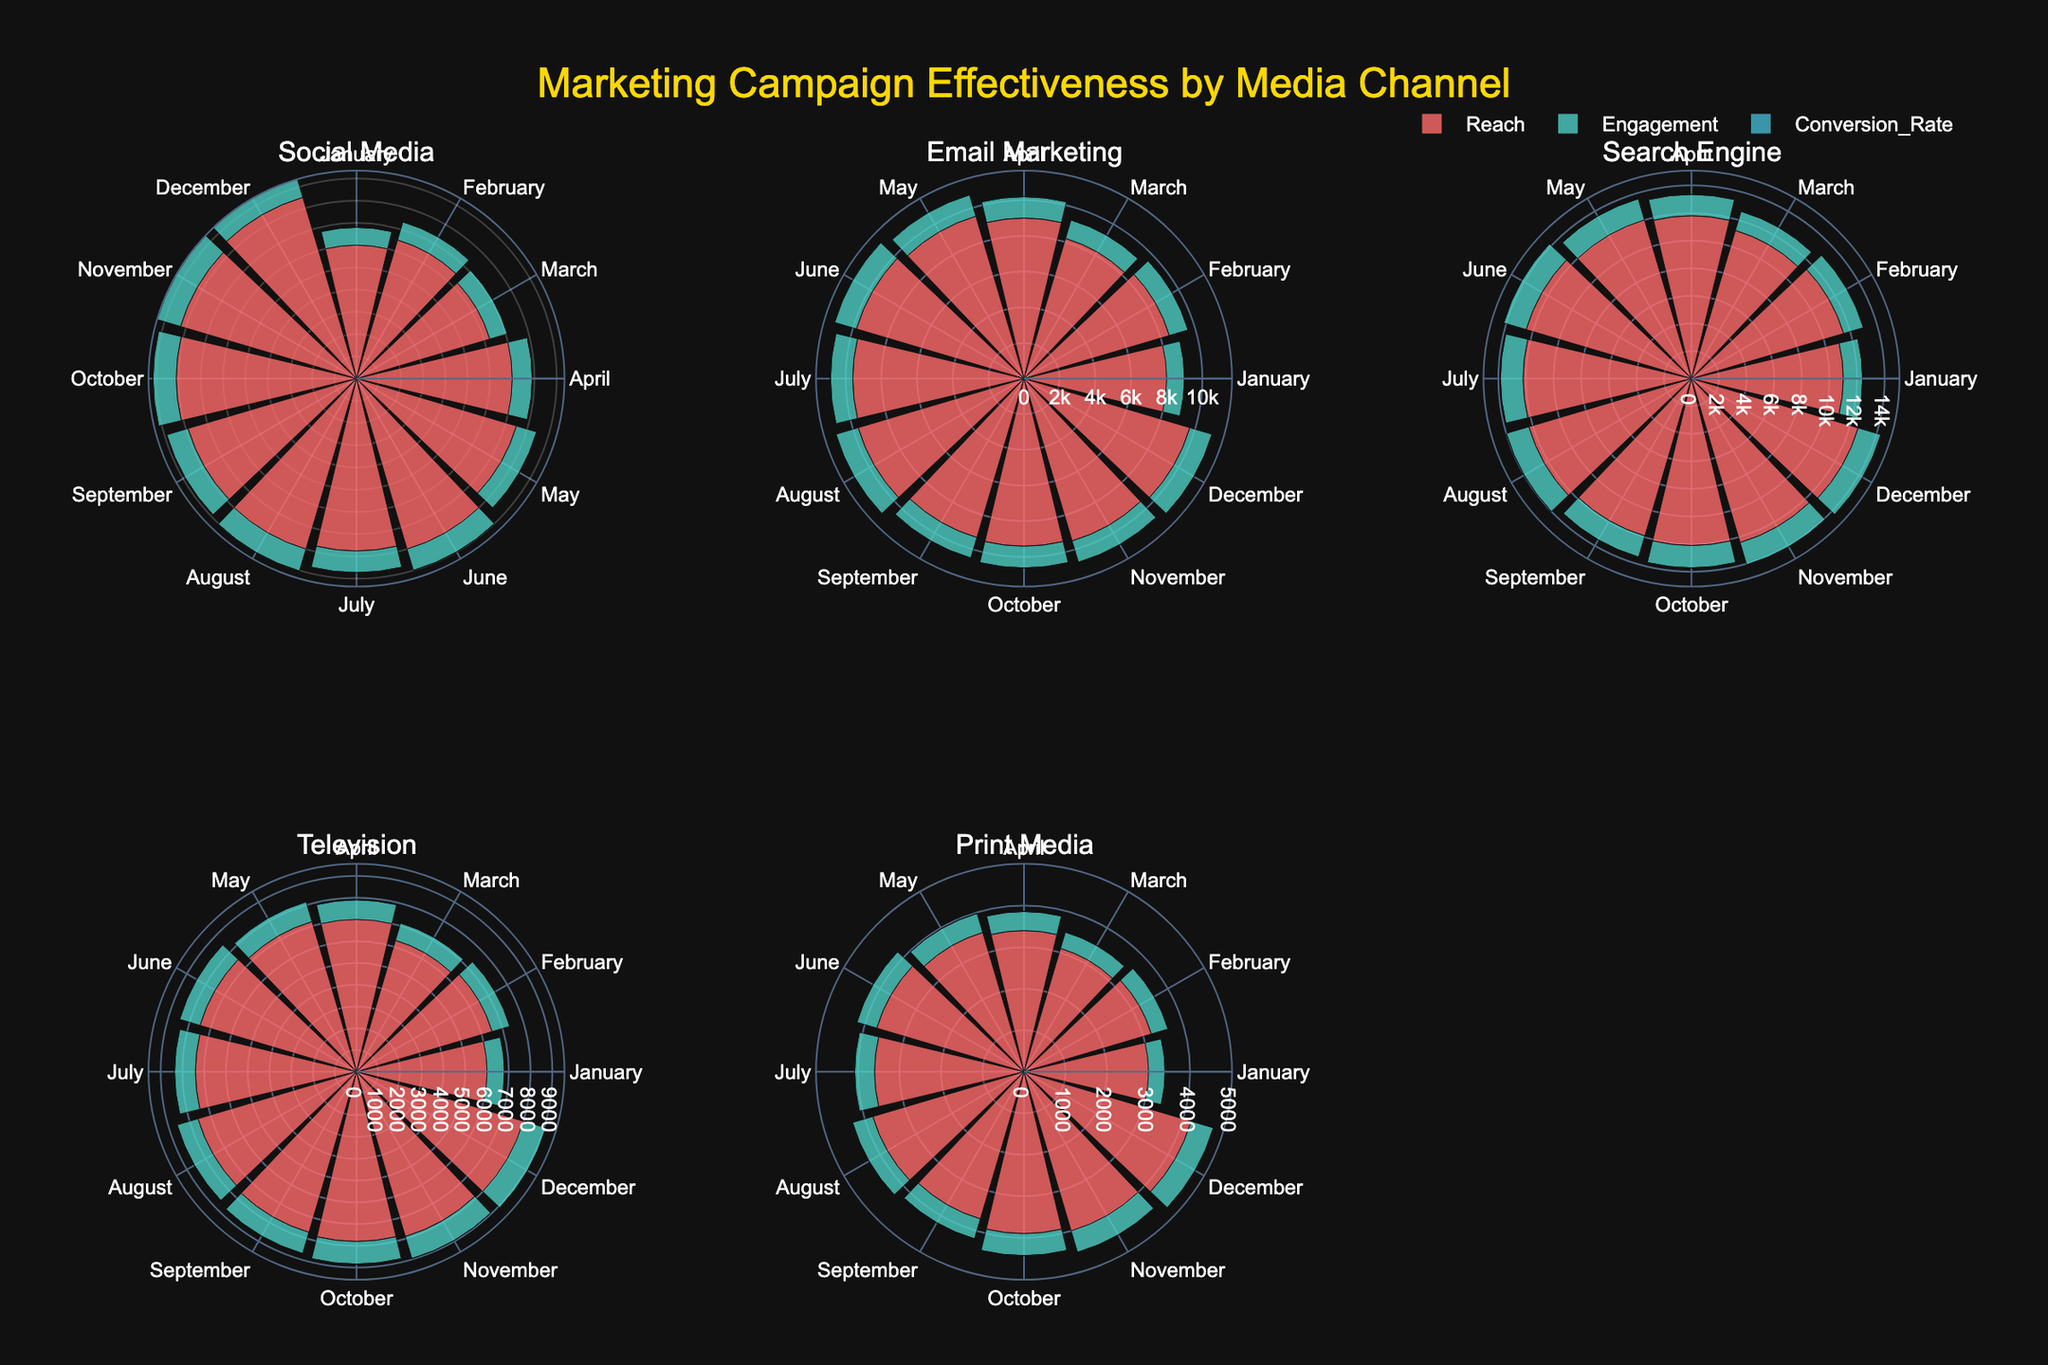What is the total number of media channels shown in the figure? The figure has a separate subplot for each media channel. By counting the subplot titles, we can determine the total number of media channels.
Answer: 5 Which month shows the highest conversion rate for Social Media? From the subplot for Social Media, identify the month corresponding to the highest bar (conversion rate series) in the "Conversion_Rate" metric.
Answer: December Which media channel has the lowest engagement in January? Check each subplot and identify the bar representing the engagement metric for January. Compare these values to find the lowest one.
Answer: Print Media In which month did Email Marketing have its lowest reach? Examine the "Reach" metric in the Email Marketing subplot and identify the month with the smallest bar value.
Answer: January Compare the reach of Social Media and Television in May. Which one is higher, and by how much? Look at the "Reach" metric bars for May in both the Social Media and Television subplots. Subtract the Television value from the Social Media value to find the difference.
Answer: Social Media by 7,800 What is the average conversion rate for Search Engine over the year? Sum up the conversion rates for each month in the Search Engine subplot and divide by the number of months (12) to calculate the average.
Answer: 0.06 Which metric had the most variability for Print Media over the year? Assess the spread of the bars for each metric (Reach, Engagement, Conversion Rate) in the Print Media subplot to determine which has the largest range (variability).
Answer: Engagement What is the median engagement in Social Media for the year? Arrange the monthly engagement values for Social Media in ascending order and find the middle value (or average the two middle values if even number).
Answer: 2,000 Does Email Marketing show a consistent conversion rate, or is there a significant variation? Compare the conversion rate bars for each month in the Email Marketing subplot to see if they are similar in height or there are noticeable differences.
Answer: Consistent 